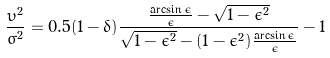<formula> <loc_0><loc_0><loc_500><loc_500>\frac { \upsilon ^ { 2 } } { \sigma ^ { 2 } } = 0 . 5 ( 1 - \delta ) \frac { \frac { \arcsin \epsilon } { \epsilon } - \sqrt { 1 - \epsilon ^ { 2 } } } { \sqrt { 1 - \epsilon ^ { 2 } } - ( 1 - \epsilon ^ { 2 } ) \frac { \arcsin \epsilon } { \epsilon } } - 1</formula> 